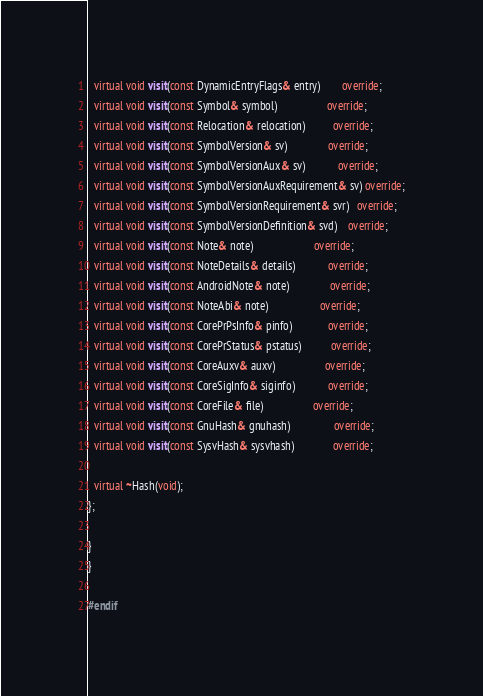<code> <loc_0><loc_0><loc_500><loc_500><_C++_>  virtual void visit(const DynamicEntryFlags& entry)        override;
  virtual void visit(const Symbol& symbol)                  override;
  virtual void visit(const Relocation& relocation)          override;
  virtual void visit(const SymbolVersion& sv)               override;
  virtual void visit(const SymbolVersionAux& sv)            override;
  virtual void visit(const SymbolVersionAuxRequirement& sv) override;
  virtual void visit(const SymbolVersionRequirement& svr)   override;
  virtual void visit(const SymbolVersionDefinition& svd)    override;
  virtual void visit(const Note& note)                      override;
  virtual void visit(const NoteDetails& details)            override;
  virtual void visit(const AndroidNote& note)               override;
  virtual void visit(const NoteAbi& note)                   override;
  virtual void visit(const CorePrPsInfo& pinfo)             override;
  virtual void visit(const CorePrStatus& pstatus)           override;
  virtual void visit(const CoreAuxv& auxv)                  override;
  virtual void visit(const CoreSigInfo& siginfo)            override;
  virtual void visit(const CoreFile& file)                  override;
  virtual void visit(const GnuHash& gnuhash)                override;
  virtual void visit(const SysvHash& sysvhash)              override;

  virtual ~Hash(void);
};

}
}

#endif
</code> 